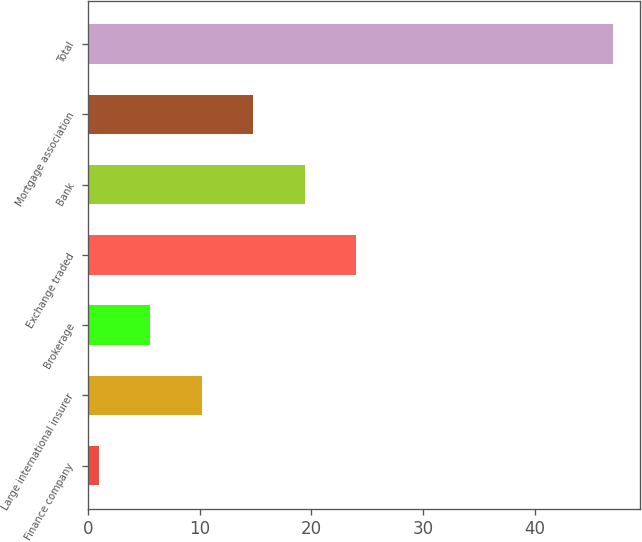Convert chart to OTSL. <chart><loc_0><loc_0><loc_500><loc_500><bar_chart><fcel>Finance company<fcel>Large international insurer<fcel>Brokerage<fcel>Exchange traded<fcel>Bank<fcel>Mortgage association<fcel>Total<nl><fcel>1<fcel>10.2<fcel>5.6<fcel>24<fcel>19.4<fcel>14.8<fcel>47<nl></chart> 